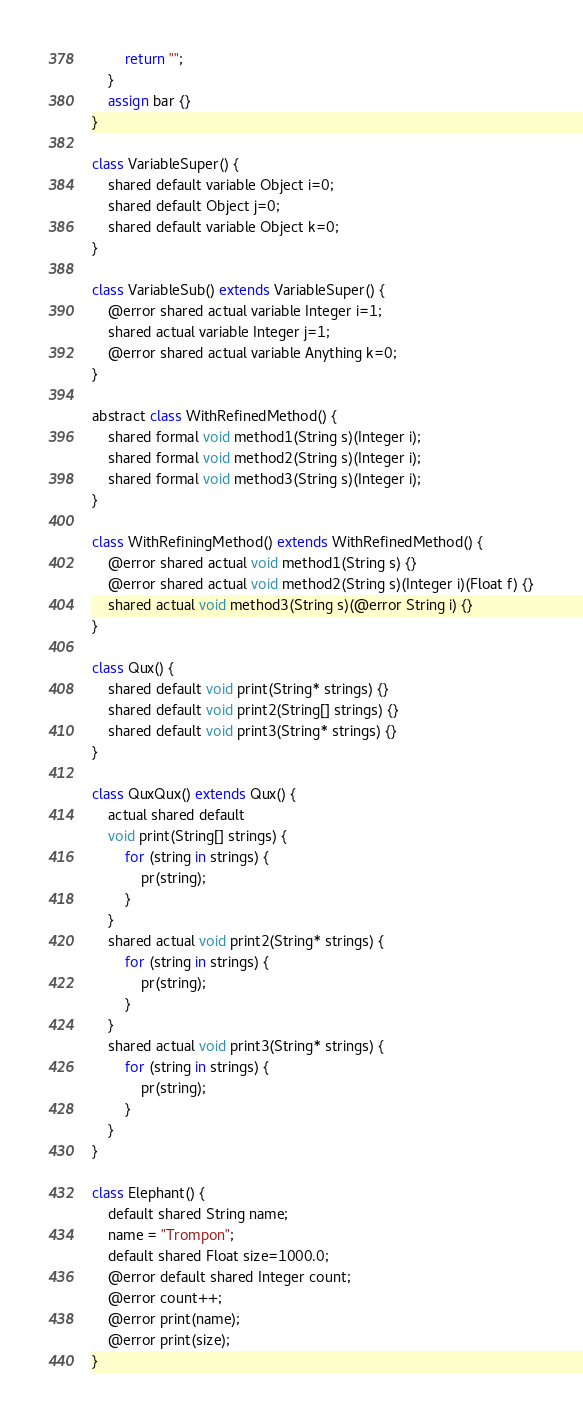Convert code to text. <code><loc_0><loc_0><loc_500><loc_500><_Ceylon_>        return "";
    }
    assign bar {}
}

class VariableSuper() {
    shared default variable Object i=0;
    shared default Object j=0;
    shared default variable Object k=0;
}

class VariableSub() extends VariableSuper() {
    @error shared actual variable Integer i=1;
    shared actual variable Integer j=1;
    @error shared actual variable Anything k=0;
}

abstract class WithRefinedMethod() {
    shared formal void method1(String s)(Integer i);
    shared formal void method2(String s)(Integer i);
    shared formal void method3(String s)(Integer i);
}

class WithRefiningMethod() extends WithRefinedMethod() {
    @error shared actual void method1(String s) {}
    @error shared actual void method2(String s)(Integer i)(Float f) {}
    shared actual void method3(String s)(@error String i) {}
}

class Qux() {
    shared default void print(String* strings) {}
    shared default void print2(String[] strings) {}
    shared default void print3(String* strings) {}
}

class QuxQux() extends Qux() {
    actual shared default 
    void print(String[] strings) {
        for (string in strings) {
            pr(string);
        }
    }
    shared actual void print2(String* strings) {
        for (string in strings) {
            pr(string);
        }
    }
    shared actual void print3(String* strings) {
        for (string in strings) {
            pr(string);
        }
    }
}

class Elephant() {
    default shared String name;
    name = "Trompon";
    default shared Float size=1000.0;
    @error default shared Integer count;
    @error count++;
    @error print(name);
    @error print(size);
}
</code> 